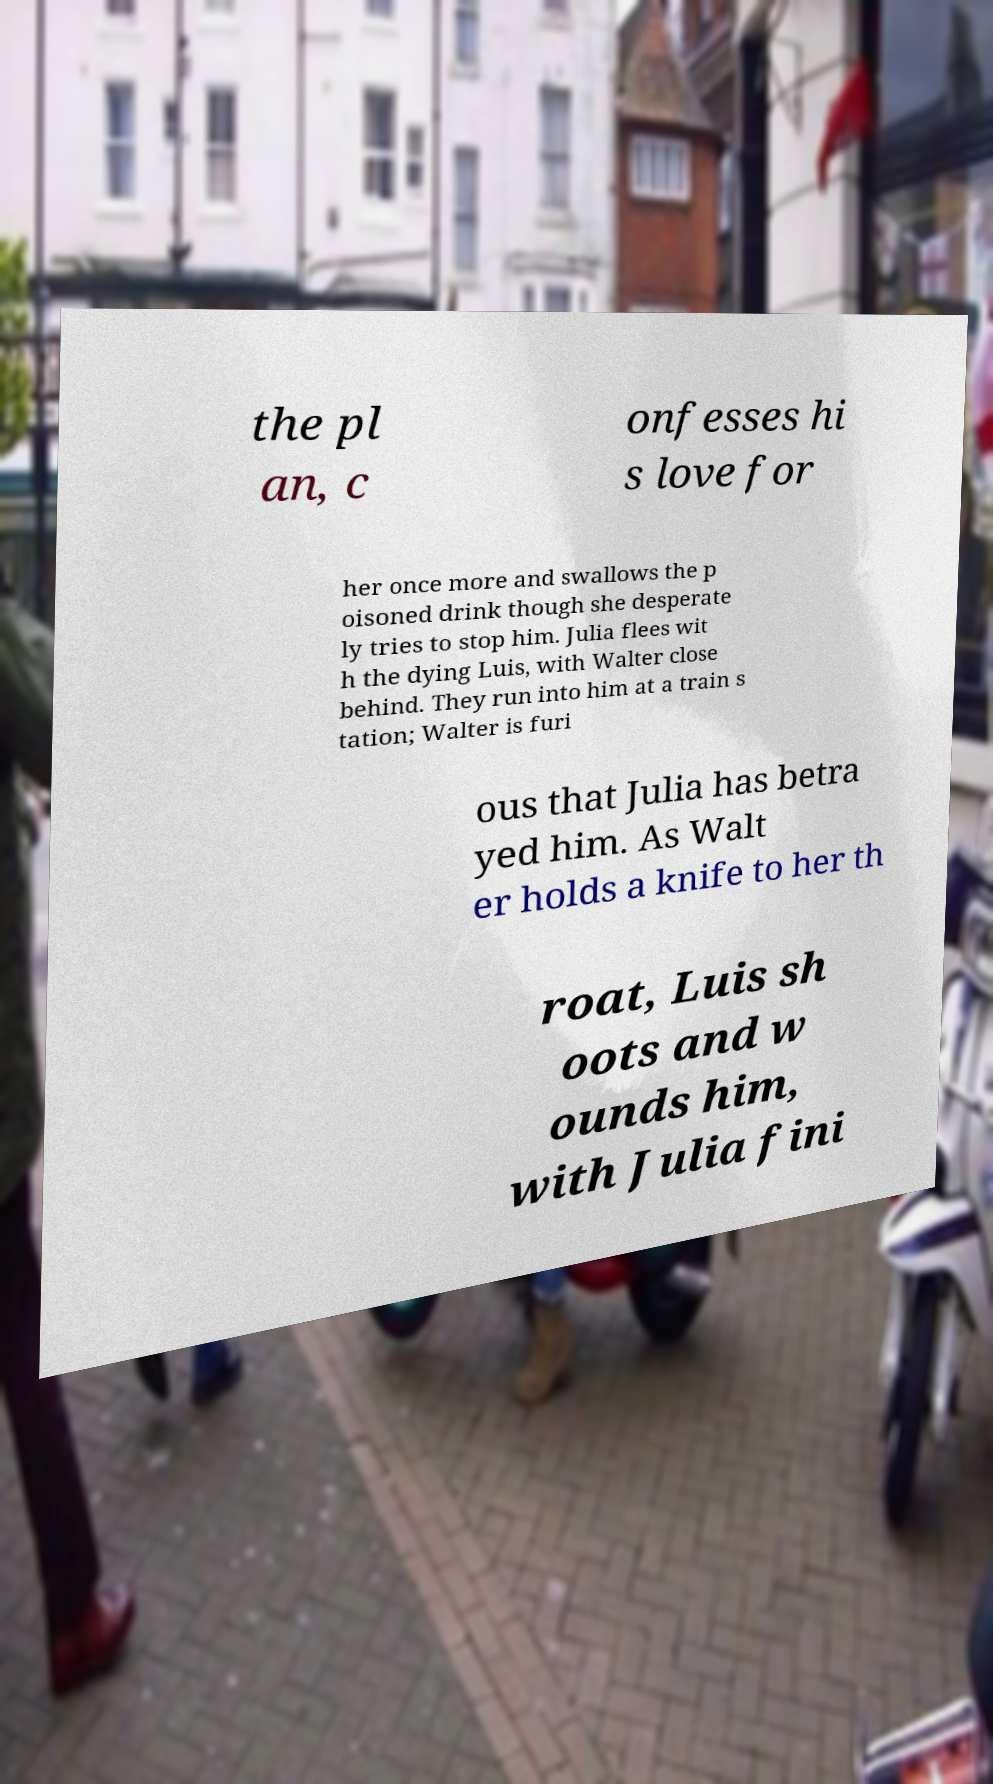Can you read and provide the text displayed in the image?This photo seems to have some interesting text. Can you extract and type it out for me? the pl an, c onfesses hi s love for her once more and swallows the p oisoned drink though she desperate ly tries to stop him. Julia flees wit h the dying Luis, with Walter close behind. They run into him at a train s tation; Walter is furi ous that Julia has betra yed him. As Walt er holds a knife to her th roat, Luis sh oots and w ounds him, with Julia fini 